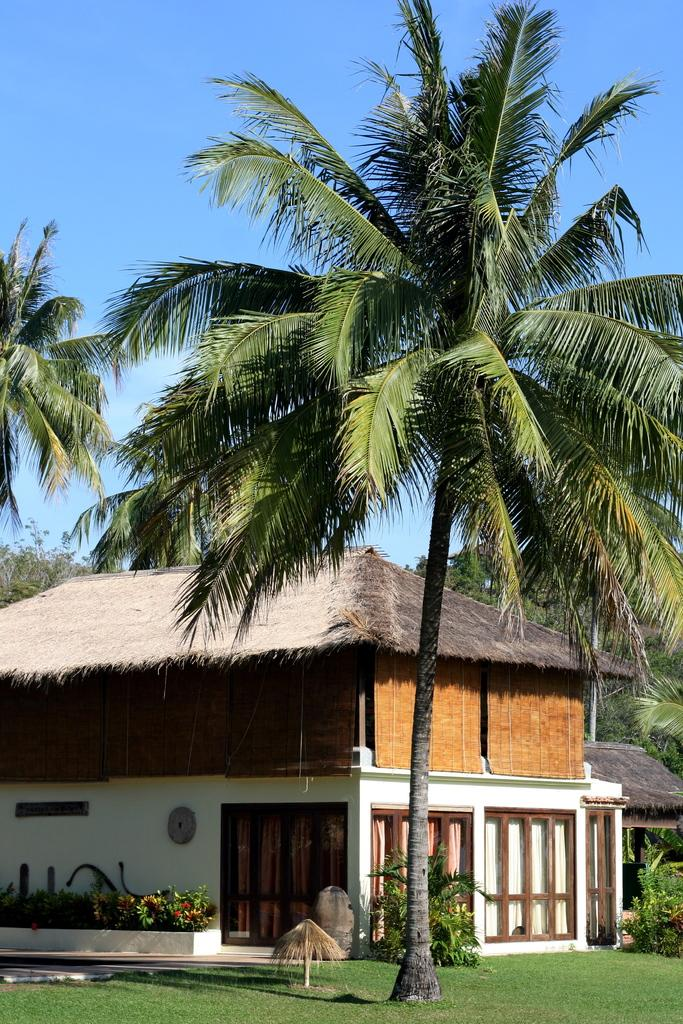What type of vegetation can be seen in the image? There are trees in the image. What type of structure is present in the image? There is a house in the image. What color is the grass in the image? The grass on the ground is green in the image. What color is the sky in the image? The sky is blue in the image. How does the respect fly in the image? There is no respect or flying object present in the image. What type of burn can be seen on the trees in the image? There are no burns or damaged trees visible in the image. 